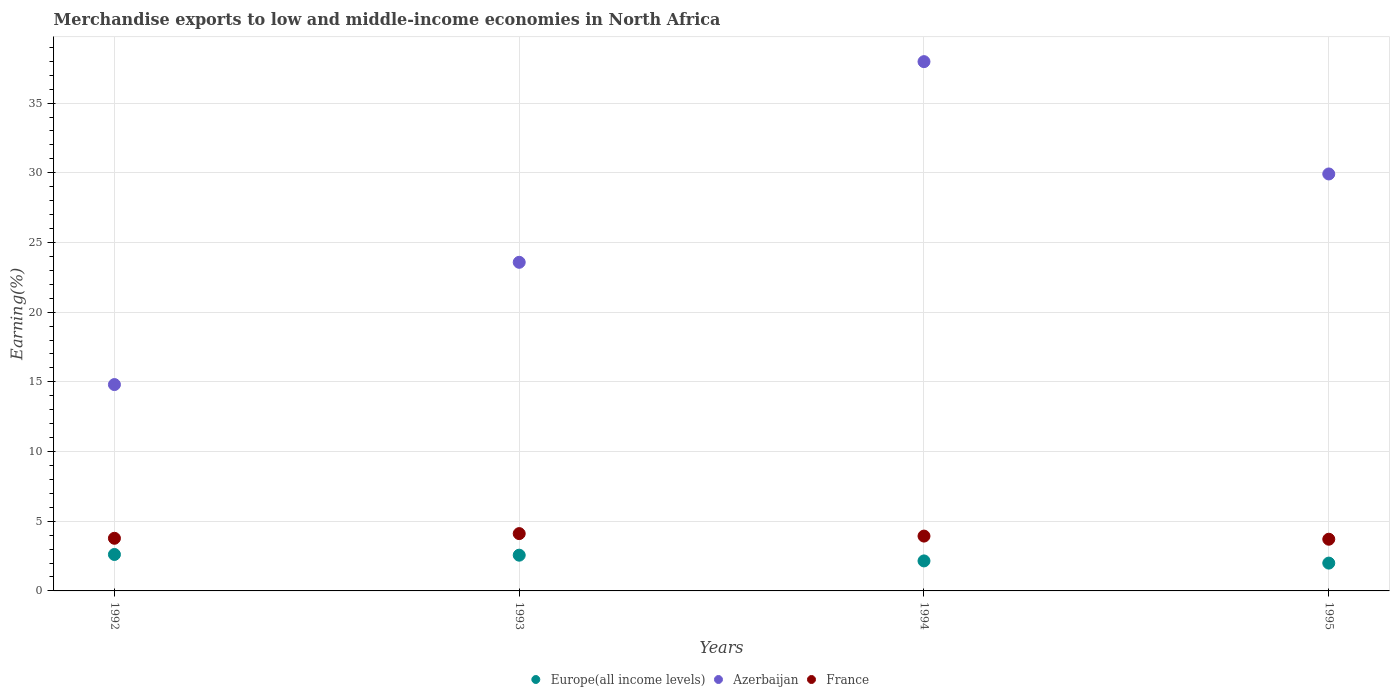Is the number of dotlines equal to the number of legend labels?
Keep it short and to the point. Yes. What is the percentage of amount earned from merchandise exports in Azerbaijan in 1994?
Ensure brevity in your answer.  37.97. Across all years, what is the maximum percentage of amount earned from merchandise exports in Azerbaijan?
Your response must be concise. 37.97. Across all years, what is the minimum percentage of amount earned from merchandise exports in France?
Your answer should be compact. 3.71. In which year was the percentage of amount earned from merchandise exports in France minimum?
Your response must be concise. 1995. What is the total percentage of amount earned from merchandise exports in Europe(all income levels) in the graph?
Offer a very short reply. 9.33. What is the difference between the percentage of amount earned from merchandise exports in Europe(all income levels) in 1993 and that in 1995?
Keep it short and to the point. 0.57. What is the difference between the percentage of amount earned from merchandise exports in Azerbaijan in 1993 and the percentage of amount earned from merchandise exports in Europe(all income levels) in 1992?
Ensure brevity in your answer.  20.96. What is the average percentage of amount earned from merchandise exports in Europe(all income levels) per year?
Provide a short and direct response. 2.33. In the year 1995, what is the difference between the percentage of amount earned from merchandise exports in Europe(all income levels) and percentage of amount earned from merchandise exports in France?
Offer a terse response. -1.71. What is the ratio of the percentage of amount earned from merchandise exports in Europe(all income levels) in 1993 to that in 1995?
Your answer should be compact. 1.28. What is the difference between the highest and the second highest percentage of amount earned from merchandise exports in Azerbaijan?
Offer a very short reply. 8.06. What is the difference between the highest and the lowest percentage of amount earned from merchandise exports in Azerbaijan?
Ensure brevity in your answer.  23.17. Is the sum of the percentage of amount earned from merchandise exports in France in 1992 and 1994 greater than the maximum percentage of amount earned from merchandise exports in Europe(all income levels) across all years?
Offer a very short reply. Yes. Is the percentage of amount earned from merchandise exports in Azerbaijan strictly greater than the percentage of amount earned from merchandise exports in Europe(all income levels) over the years?
Offer a very short reply. Yes. What is the difference between two consecutive major ticks on the Y-axis?
Provide a short and direct response. 5. Does the graph contain any zero values?
Ensure brevity in your answer.  No. How many legend labels are there?
Ensure brevity in your answer.  3. How are the legend labels stacked?
Offer a very short reply. Horizontal. What is the title of the graph?
Your answer should be compact. Merchandise exports to low and middle-income economies in North Africa. Does "Somalia" appear as one of the legend labels in the graph?
Your answer should be very brief. No. What is the label or title of the Y-axis?
Provide a short and direct response. Earning(%). What is the Earning(%) in Europe(all income levels) in 1992?
Offer a terse response. 2.61. What is the Earning(%) of Azerbaijan in 1992?
Your answer should be compact. 14.81. What is the Earning(%) of France in 1992?
Offer a very short reply. 3.78. What is the Earning(%) in Europe(all income levels) in 1993?
Give a very brief answer. 2.56. What is the Earning(%) of Azerbaijan in 1993?
Ensure brevity in your answer.  23.58. What is the Earning(%) of France in 1993?
Ensure brevity in your answer.  4.11. What is the Earning(%) of Europe(all income levels) in 1994?
Your answer should be compact. 2.15. What is the Earning(%) in Azerbaijan in 1994?
Provide a succinct answer. 37.97. What is the Earning(%) of France in 1994?
Offer a very short reply. 3.93. What is the Earning(%) in Europe(all income levels) in 1995?
Ensure brevity in your answer.  2. What is the Earning(%) of Azerbaijan in 1995?
Your answer should be very brief. 29.92. What is the Earning(%) of France in 1995?
Ensure brevity in your answer.  3.71. Across all years, what is the maximum Earning(%) in Europe(all income levels)?
Your answer should be very brief. 2.61. Across all years, what is the maximum Earning(%) of Azerbaijan?
Provide a succinct answer. 37.97. Across all years, what is the maximum Earning(%) in France?
Ensure brevity in your answer.  4.11. Across all years, what is the minimum Earning(%) of Europe(all income levels)?
Offer a very short reply. 2. Across all years, what is the minimum Earning(%) in Azerbaijan?
Keep it short and to the point. 14.81. Across all years, what is the minimum Earning(%) in France?
Provide a succinct answer. 3.71. What is the total Earning(%) in Europe(all income levels) in the graph?
Offer a terse response. 9.33. What is the total Earning(%) in Azerbaijan in the graph?
Your answer should be compact. 106.27. What is the total Earning(%) of France in the graph?
Offer a terse response. 15.53. What is the difference between the Earning(%) in Europe(all income levels) in 1992 and that in 1993?
Your answer should be very brief. 0.05. What is the difference between the Earning(%) in Azerbaijan in 1992 and that in 1993?
Offer a terse response. -8.77. What is the difference between the Earning(%) in France in 1992 and that in 1993?
Offer a terse response. -0.34. What is the difference between the Earning(%) in Europe(all income levels) in 1992 and that in 1994?
Provide a short and direct response. 0.46. What is the difference between the Earning(%) of Azerbaijan in 1992 and that in 1994?
Your answer should be very brief. -23.17. What is the difference between the Earning(%) of France in 1992 and that in 1994?
Keep it short and to the point. -0.16. What is the difference between the Earning(%) of Europe(all income levels) in 1992 and that in 1995?
Offer a very short reply. 0.62. What is the difference between the Earning(%) of Azerbaijan in 1992 and that in 1995?
Make the answer very short. -15.11. What is the difference between the Earning(%) in France in 1992 and that in 1995?
Your answer should be very brief. 0.07. What is the difference between the Earning(%) in Europe(all income levels) in 1993 and that in 1994?
Your response must be concise. 0.41. What is the difference between the Earning(%) of Azerbaijan in 1993 and that in 1994?
Provide a succinct answer. -14.4. What is the difference between the Earning(%) in France in 1993 and that in 1994?
Make the answer very short. 0.18. What is the difference between the Earning(%) in Europe(all income levels) in 1993 and that in 1995?
Your answer should be compact. 0.57. What is the difference between the Earning(%) of Azerbaijan in 1993 and that in 1995?
Make the answer very short. -6.34. What is the difference between the Earning(%) in France in 1993 and that in 1995?
Make the answer very short. 0.4. What is the difference between the Earning(%) of Europe(all income levels) in 1994 and that in 1995?
Offer a terse response. 0.16. What is the difference between the Earning(%) in Azerbaijan in 1994 and that in 1995?
Keep it short and to the point. 8.06. What is the difference between the Earning(%) in France in 1994 and that in 1995?
Make the answer very short. 0.22. What is the difference between the Earning(%) in Europe(all income levels) in 1992 and the Earning(%) in Azerbaijan in 1993?
Make the answer very short. -20.96. What is the difference between the Earning(%) of Europe(all income levels) in 1992 and the Earning(%) of France in 1993?
Provide a short and direct response. -1.5. What is the difference between the Earning(%) of Azerbaijan in 1992 and the Earning(%) of France in 1993?
Provide a short and direct response. 10.69. What is the difference between the Earning(%) of Europe(all income levels) in 1992 and the Earning(%) of Azerbaijan in 1994?
Keep it short and to the point. -35.36. What is the difference between the Earning(%) in Europe(all income levels) in 1992 and the Earning(%) in France in 1994?
Offer a terse response. -1.32. What is the difference between the Earning(%) of Azerbaijan in 1992 and the Earning(%) of France in 1994?
Offer a very short reply. 10.87. What is the difference between the Earning(%) of Europe(all income levels) in 1992 and the Earning(%) of Azerbaijan in 1995?
Provide a succinct answer. -27.3. What is the difference between the Earning(%) of Europe(all income levels) in 1992 and the Earning(%) of France in 1995?
Provide a short and direct response. -1.09. What is the difference between the Earning(%) of Azerbaijan in 1992 and the Earning(%) of France in 1995?
Your answer should be compact. 11.1. What is the difference between the Earning(%) in Europe(all income levels) in 1993 and the Earning(%) in Azerbaijan in 1994?
Ensure brevity in your answer.  -35.41. What is the difference between the Earning(%) in Europe(all income levels) in 1993 and the Earning(%) in France in 1994?
Keep it short and to the point. -1.37. What is the difference between the Earning(%) of Azerbaijan in 1993 and the Earning(%) of France in 1994?
Give a very brief answer. 19.64. What is the difference between the Earning(%) in Europe(all income levels) in 1993 and the Earning(%) in Azerbaijan in 1995?
Your answer should be very brief. -27.35. What is the difference between the Earning(%) in Europe(all income levels) in 1993 and the Earning(%) in France in 1995?
Give a very brief answer. -1.14. What is the difference between the Earning(%) of Azerbaijan in 1993 and the Earning(%) of France in 1995?
Give a very brief answer. 19.87. What is the difference between the Earning(%) in Europe(all income levels) in 1994 and the Earning(%) in Azerbaijan in 1995?
Your response must be concise. -27.76. What is the difference between the Earning(%) in Europe(all income levels) in 1994 and the Earning(%) in France in 1995?
Provide a short and direct response. -1.56. What is the difference between the Earning(%) of Azerbaijan in 1994 and the Earning(%) of France in 1995?
Your response must be concise. 34.26. What is the average Earning(%) in Europe(all income levels) per year?
Make the answer very short. 2.33. What is the average Earning(%) in Azerbaijan per year?
Keep it short and to the point. 26.57. What is the average Earning(%) of France per year?
Provide a short and direct response. 3.88. In the year 1992, what is the difference between the Earning(%) in Europe(all income levels) and Earning(%) in Azerbaijan?
Ensure brevity in your answer.  -12.19. In the year 1992, what is the difference between the Earning(%) of Europe(all income levels) and Earning(%) of France?
Make the answer very short. -1.16. In the year 1992, what is the difference between the Earning(%) of Azerbaijan and Earning(%) of France?
Your response must be concise. 11.03. In the year 1993, what is the difference between the Earning(%) of Europe(all income levels) and Earning(%) of Azerbaijan?
Offer a terse response. -21.01. In the year 1993, what is the difference between the Earning(%) of Europe(all income levels) and Earning(%) of France?
Ensure brevity in your answer.  -1.55. In the year 1993, what is the difference between the Earning(%) in Azerbaijan and Earning(%) in France?
Your answer should be very brief. 19.46. In the year 1994, what is the difference between the Earning(%) in Europe(all income levels) and Earning(%) in Azerbaijan?
Offer a very short reply. -35.82. In the year 1994, what is the difference between the Earning(%) of Europe(all income levels) and Earning(%) of France?
Make the answer very short. -1.78. In the year 1994, what is the difference between the Earning(%) of Azerbaijan and Earning(%) of France?
Give a very brief answer. 34.04. In the year 1995, what is the difference between the Earning(%) in Europe(all income levels) and Earning(%) in Azerbaijan?
Your response must be concise. -27.92. In the year 1995, what is the difference between the Earning(%) of Europe(all income levels) and Earning(%) of France?
Offer a very short reply. -1.71. In the year 1995, what is the difference between the Earning(%) of Azerbaijan and Earning(%) of France?
Keep it short and to the point. 26.21. What is the ratio of the Earning(%) of Europe(all income levels) in 1992 to that in 1993?
Make the answer very short. 1.02. What is the ratio of the Earning(%) in Azerbaijan in 1992 to that in 1993?
Give a very brief answer. 0.63. What is the ratio of the Earning(%) of France in 1992 to that in 1993?
Keep it short and to the point. 0.92. What is the ratio of the Earning(%) of Europe(all income levels) in 1992 to that in 1994?
Make the answer very short. 1.21. What is the ratio of the Earning(%) in Azerbaijan in 1992 to that in 1994?
Make the answer very short. 0.39. What is the ratio of the Earning(%) in France in 1992 to that in 1994?
Provide a short and direct response. 0.96. What is the ratio of the Earning(%) of Europe(all income levels) in 1992 to that in 1995?
Provide a short and direct response. 1.31. What is the ratio of the Earning(%) in Azerbaijan in 1992 to that in 1995?
Your answer should be very brief. 0.49. What is the ratio of the Earning(%) of France in 1992 to that in 1995?
Offer a terse response. 1.02. What is the ratio of the Earning(%) in Europe(all income levels) in 1993 to that in 1994?
Your response must be concise. 1.19. What is the ratio of the Earning(%) of Azerbaijan in 1993 to that in 1994?
Ensure brevity in your answer.  0.62. What is the ratio of the Earning(%) in France in 1993 to that in 1994?
Give a very brief answer. 1.05. What is the ratio of the Earning(%) of Europe(all income levels) in 1993 to that in 1995?
Give a very brief answer. 1.28. What is the ratio of the Earning(%) in Azerbaijan in 1993 to that in 1995?
Offer a terse response. 0.79. What is the ratio of the Earning(%) of France in 1993 to that in 1995?
Provide a succinct answer. 1.11. What is the ratio of the Earning(%) of Europe(all income levels) in 1994 to that in 1995?
Give a very brief answer. 1.08. What is the ratio of the Earning(%) in Azerbaijan in 1994 to that in 1995?
Your answer should be compact. 1.27. What is the ratio of the Earning(%) of France in 1994 to that in 1995?
Your answer should be compact. 1.06. What is the difference between the highest and the second highest Earning(%) in Europe(all income levels)?
Offer a terse response. 0.05. What is the difference between the highest and the second highest Earning(%) of Azerbaijan?
Your response must be concise. 8.06. What is the difference between the highest and the second highest Earning(%) in France?
Provide a short and direct response. 0.18. What is the difference between the highest and the lowest Earning(%) of Europe(all income levels)?
Your response must be concise. 0.62. What is the difference between the highest and the lowest Earning(%) of Azerbaijan?
Your answer should be very brief. 23.17. What is the difference between the highest and the lowest Earning(%) of France?
Provide a short and direct response. 0.4. 